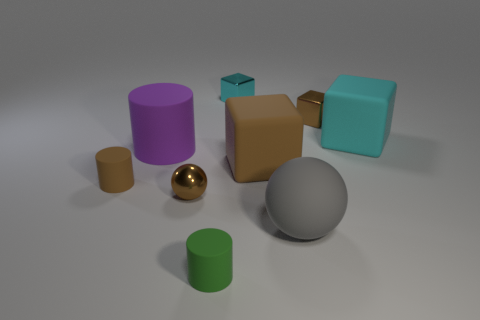Subtract all small brown cylinders. How many cylinders are left? 2 Subtract all cyan cylinders. How many brown cubes are left? 2 Subtract all purple cylinders. How many cylinders are left? 2 Subtract all cylinders. How many objects are left? 6 Add 1 large rubber balls. How many objects exist? 10 Subtract 1 cylinders. How many cylinders are left? 2 Subtract all gray cylinders. Subtract all purple spheres. How many cylinders are left? 3 Subtract all blue metal cubes. Subtract all big spheres. How many objects are left? 8 Add 1 small rubber objects. How many small rubber objects are left? 3 Add 2 tiny brown rubber things. How many tiny brown rubber things exist? 3 